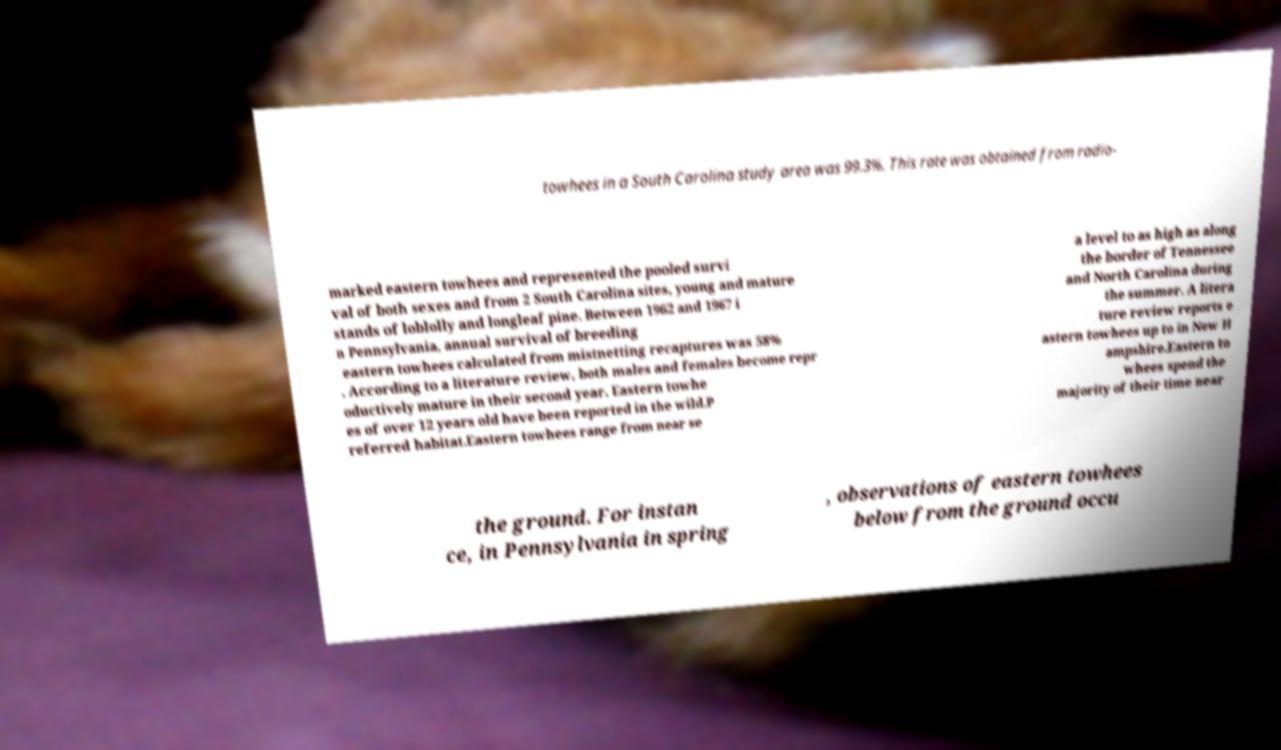Can you accurately transcribe the text from the provided image for me? towhees in a South Carolina study area was 99.3%. This rate was obtained from radio- marked eastern towhees and represented the pooled survi val of both sexes and from 2 South Carolina sites, young and mature stands of loblolly and longleaf pine. Between 1962 and 1967 i n Pennsylvania, annual survival of breeding eastern towhees calculated from mistnetting recaptures was 58% . According to a literature review, both males and females become repr oductively mature in their second year. Eastern towhe es of over 12 years old have been reported in the wild.P referred habitat.Eastern towhees range from near se a level to as high as along the border of Tennessee and North Carolina during the summer. A litera ture review reports e astern towhees up to in New H ampshire.Eastern to whees spend the majority of their time near the ground. For instan ce, in Pennsylvania in spring , observations of eastern towhees below from the ground occu 